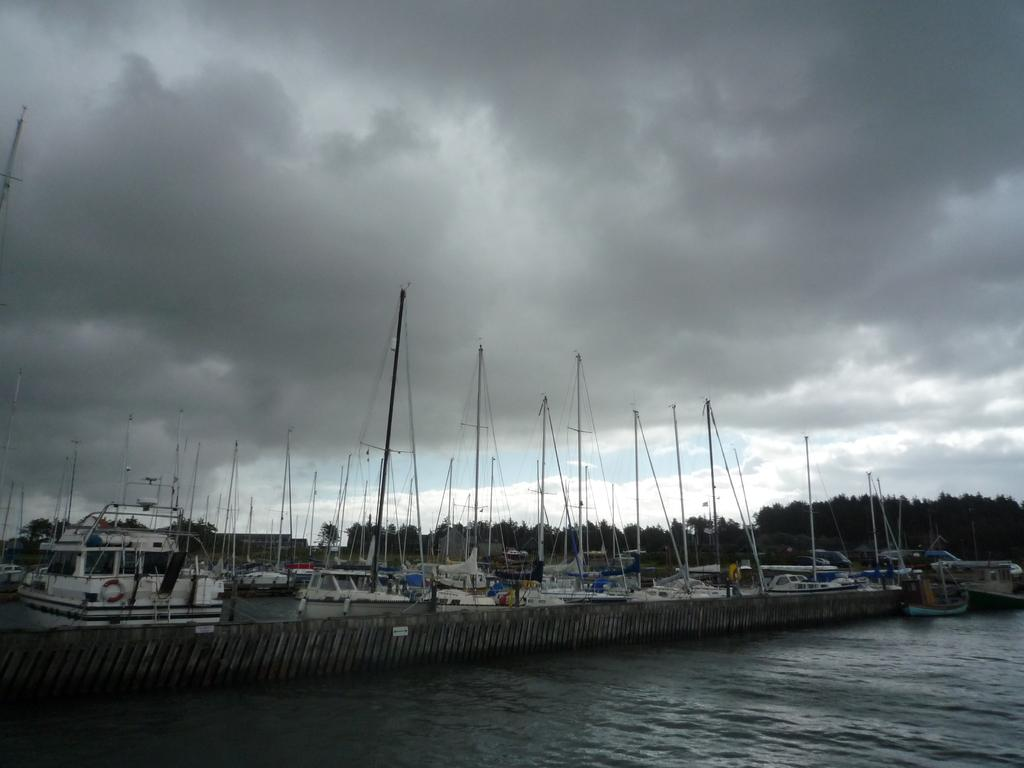What is the main subject of the image? The main subject of the image is boats. Where are the boats located? The boats are on the water. What can be seen in the background of the image? There are trees and the sky visible in the background of the image. What type of zephyr can be seen blowing through the trees in the image? There is no zephyr present in the image, and the trees do not show any signs of wind. 